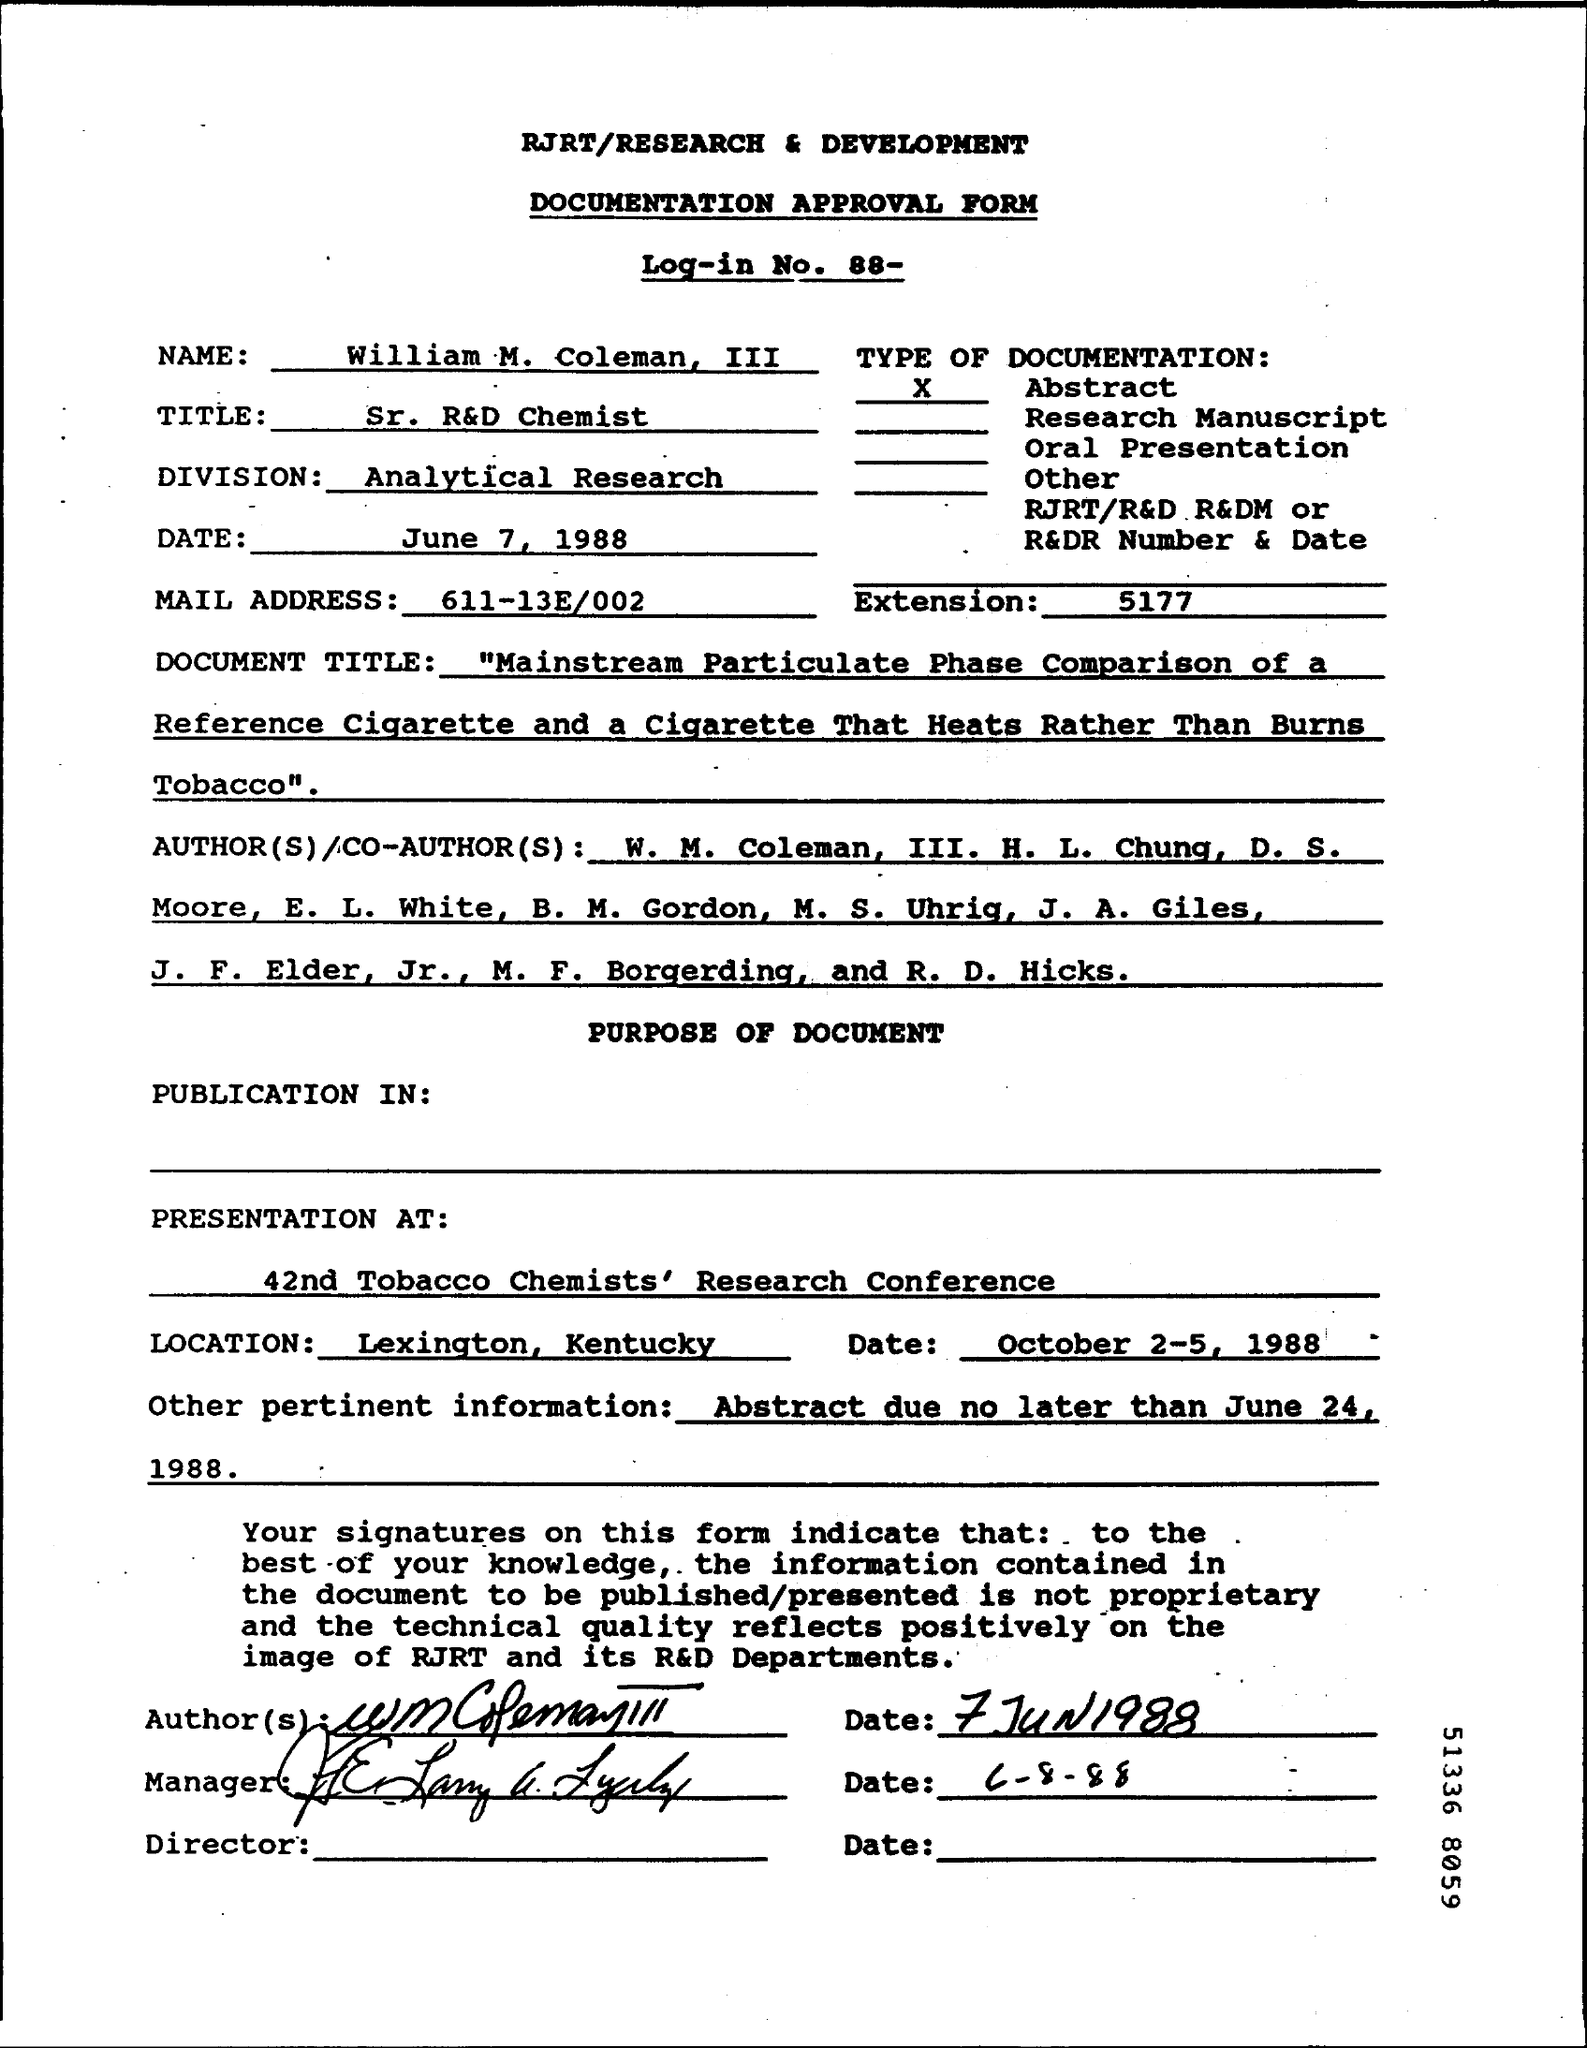Indicate a few pertinent items in this graphic. The log-in number is 88. The type of documentation is abstract. This is a documentation approval form. William M. Coleman, III is the name given. The abstract for the project is due no later than June 24, 1988 and any additional relevant information must be provided. 